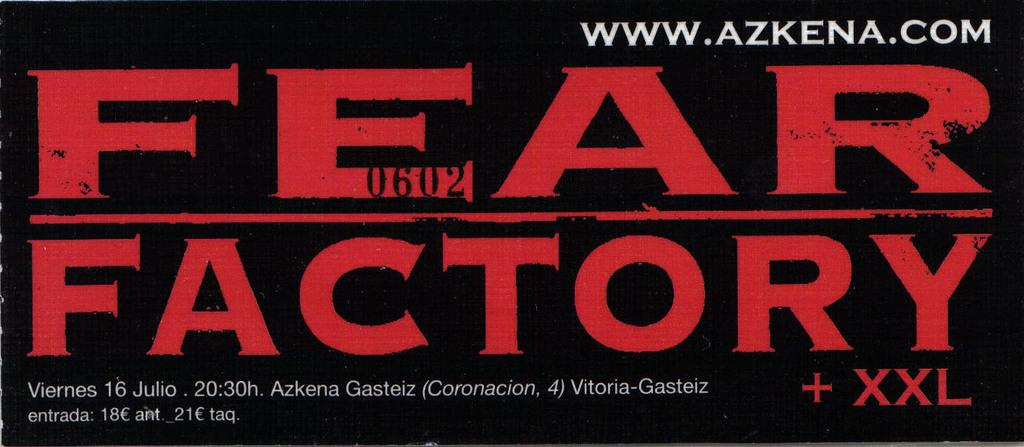<image>
Offer a succinct explanation of the picture presented. A black and red sticker that says Fear Factory. 